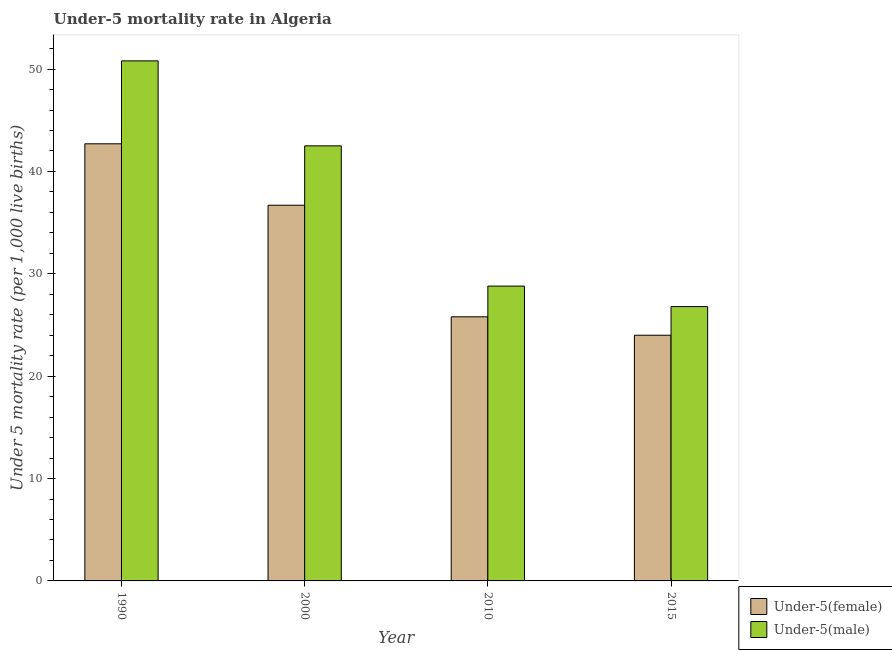How many different coloured bars are there?
Provide a short and direct response. 2. How many groups of bars are there?
Offer a terse response. 4. Are the number of bars on each tick of the X-axis equal?
Your answer should be very brief. Yes. How many bars are there on the 2nd tick from the left?
Ensure brevity in your answer.  2. What is the label of the 3rd group of bars from the left?
Offer a terse response. 2010. What is the under-5 female mortality rate in 2000?
Keep it short and to the point. 36.7. Across all years, what is the maximum under-5 female mortality rate?
Give a very brief answer. 42.7. In which year was the under-5 female mortality rate minimum?
Ensure brevity in your answer.  2015. What is the total under-5 female mortality rate in the graph?
Provide a succinct answer. 129.2. What is the difference between the under-5 male mortality rate in 1990 and that in 2015?
Offer a very short reply. 24. What is the difference between the under-5 male mortality rate in 1990 and the under-5 female mortality rate in 2010?
Your response must be concise. 22. What is the average under-5 male mortality rate per year?
Your response must be concise. 37.23. In the year 2015, what is the difference between the under-5 female mortality rate and under-5 male mortality rate?
Ensure brevity in your answer.  0. In how many years, is the under-5 female mortality rate greater than 6?
Your answer should be very brief. 4. What is the ratio of the under-5 female mortality rate in 2000 to that in 2015?
Provide a short and direct response. 1.53. What is the difference between the highest and the second highest under-5 female mortality rate?
Provide a short and direct response. 6. What is the difference between the highest and the lowest under-5 female mortality rate?
Your answer should be compact. 18.7. In how many years, is the under-5 female mortality rate greater than the average under-5 female mortality rate taken over all years?
Provide a short and direct response. 2. What does the 1st bar from the left in 2000 represents?
Offer a very short reply. Under-5(female). What does the 1st bar from the right in 2000 represents?
Provide a succinct answer. Under-5(male). Are all the bars in the graph horizontal?
Provide a short and direct response. No. Where does the legend appear in the graph?
Your answer should be compact. Bottom right. What is the title of the graph?
Offer a terse response. Under-5 mortality rate in Algeria. What is the label or title of the Y-axis?
Keep it short and to the point. Under 5 mortality rate (per 1,0 live births). What is the Under 5 mortality rate (per 1,000 live births) in Under-5(female) in 1990?
Keep it short and to the point. 42.7. What is the Under 5 mortality rate (per 1,000 live births) of Under-5(male) in 1990?
Provide a succinct answer. 50.8. What is the Under 5 mortality rate (per 1,000 live births) in Under-5(female) in 2000?
Provide a short and direct response. 36.7. What is the Under 5 mortality rate (per 1,000 live births) of Under-5(male) in 2000?
Ensure brevity in your answer.  42.5. What is the Under 5 mortality rate (per 1,000 live births) in Under-5(female) in 2010?
Offer a terse response. 25.8. What is the Under 5 mortality rate (per 1,000 live births) of Under-5(male) in 2010?
Give a very brief answer. 28.8. What is the Under 5 mortality rate (per 1,000 live births) in Under-5(female) in 2015?
Ensure brevity in your answer.  24. What is the Under 5 mortality rate (per 1,000 live births) in Under-5(male) in 2015?
Your answer should be very brief. 26.8. Across all years, what is the maximum Under 5 mortality rate (per 1,000 live births) in Under-5(female)?
Provide a short and direct response. 42.7. Across all years, what is the maximum Under 5 mortality rate (per 1,000 live births) in Under-5(male)?
Ensure brevity in your answer.  50.8. Across all years, what is the minimum Under 5 mortality rate (per 1,000 live births) of Under-5(female)?
Provide a short and direct response. 24. Across all years, what is the minimum Under 5 mortality rate (per 1,000 live births) in Under-5(male)?
Offer a very short reply. 26.8. What is the total Under 5 mortality rate (per 1,000 live births) of Under-5(female) in the graph?
Offer a very short reply. 129.2. What is the total Under 5 mortality rate (per 1,000 live births) in Under-5(male) in the graph?
Your response must be concise. 148.9. What is the difference between the Under 5 mortality rate (per 1,000 live births) in Under-5(male) in 1990 and that in 2000?
Ensure brevity in your answer.  8.3. What is the difference between the Under 5 mortality rate (per 1,000 live births) in Under-5(female) in 1990 and that in 2010?
Offer a very short reply. 16.9. What is the difference between the Under 5 mortality rate (per 1,000 live births) of Under-5(female) in 1990 and that in 2015?
Offer a terse response. 18.7. What is the difference between the Under 5 mortality rate (per 1,000 live births) of Under-5(female) in 2010 and that in 2015?
Your answer should be compact. 1.8. What is the difference between the Under 5 mortality rate (per 1,000 live births) of Under-5(female) in 1990 and the Under 5 mortality rate (per 1,000 live births) of Under-5(male) in 2000?
Make the answer very short. 0.2. What is the average Under 5 mortality rate (per 1,000 live births) of Under-5(female) per year?
Make the answer very short. 32.3. What is the average Under 5 mortality rate (per 1,000 live births) in Under-5(male) per year?
Your answer should be compact. 37.23. In the year 1990, what is the difference between the Under 5 mortality rate (per 1,000 live births) in Under-5(female) and Under 5 mortality rate (per 1,000 live births) in Under-5(male)?
Your answer should be very brief. -8.1. In the year 2000, what is the difference between the Under 5 mortality rate (per 1,000 live births) of Under-5(female) and Under 5 mortality rate (per 1,000 live births) of Under-5(male)?
Offer a terse response. -5.8. In the year 2010, what is the difference between the Under 5 mortality rate (per 1,000 live births) of Under-5(female) and Under 5 mortality rate (per 1,000 live births) of Under-5(male)?
Ensure brevity in your answer.  -3. In the year 2015, what is the difference between the Under 5 mortality rate (per 1,000 live births) of Under-5(female) and Under 5 mortality rate (per 1,000 live births) of Under-5(male)?
Your answer should be compact. -2.8. What is the ratio of the Under 5 mortality rate (per 1,000 live births) in Under-5(female) in 1990 to that in 2000?
Ensure brevity in your answer.  1.16. What is the ratio of the Under 5 mortality rate (per 1,000 live births) of Under-5(male) in 1990 to that in 2000?
Your answer should be compact. 1.2. What is the ratio of the Under 5 mortality rate (per 1,000 live births) of Under-5(female) in 1990 to that in 2010?
Ensure brevity in your answer.  1.66. What is the ratio of the Under 5 mortality rate (per 1,000 live births) of Under-5(male) in 1990 to that in 2010?
Your answer should be compact. 1.76. What is the ratio of the Under 5 mortality rate (per 1,000 live births) of Under-5(female) in 1990 to that in 2015?
Your answer should be very brief. 1.78. What is the ratio of the Under 5 mortality rate (per 1,000 live births) of Under-5(male) in 1990 to that in 2015?
Your response must be concise. 1.9. What is the ratio of the Under 5 mortality rate (per 1,000 live births) of Under-5(female) in 2000 to that in 2010?
Keep it short and to the point. 1.42. What is the ratio of the Under 5 mortality rate (per 1,000 live births) of Under-5(male) in 2000 to that in 2010?
Keep it short and to the point. 1.48. What is the ratio of the Under 5 mortality rate (per 1,000 live births) of Under-5(female) in 2000 to that in 2015?
Make the answer very short. 1.53. What is the ratio of the Under 5 mortality rate (per 1,000 live births) of Under-5(male) in 2000 to that in 2015?
Provide a short and direct response. 1.59. What is the ratio of the Under 5 mortality rate (per 1,000 live births) of Under-5(female) in 2010 to that in 2015?
Your answer should be compact. 1.07. What is the ratio of the Under 5 mortality rate (per 1,000 live births) of Under-5(male) in 2010 to that in 2015?
Ensure brevity in your answer.  1.07. What is the difference between the highest and the second highest Under 5 mortality rate (per 1,000 live births) of Under-5(male)?
Offer a very short reply. 8.3. What is the difference between the highest and the lowest Under 5 mortality rate (per 1,000 live births) of Under-5(female)?
Your answer should be very brief. 18.7. 